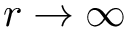Convert formula to latex. <formula><loc_0><loc_0><loc_500><loc_500>r \to \infty</formula> 